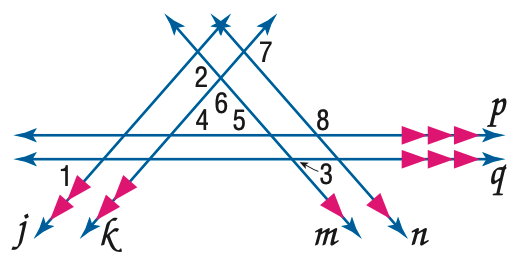Answer the mathemtical geometry problem and directly provide the correct option letter.
Question: In the figure, m \angle 1 = 50 and m \angle 3 = 60. Find the measure of \angle 2.
Choices: A: 100 B: 110 C: 120 D: 130 B 